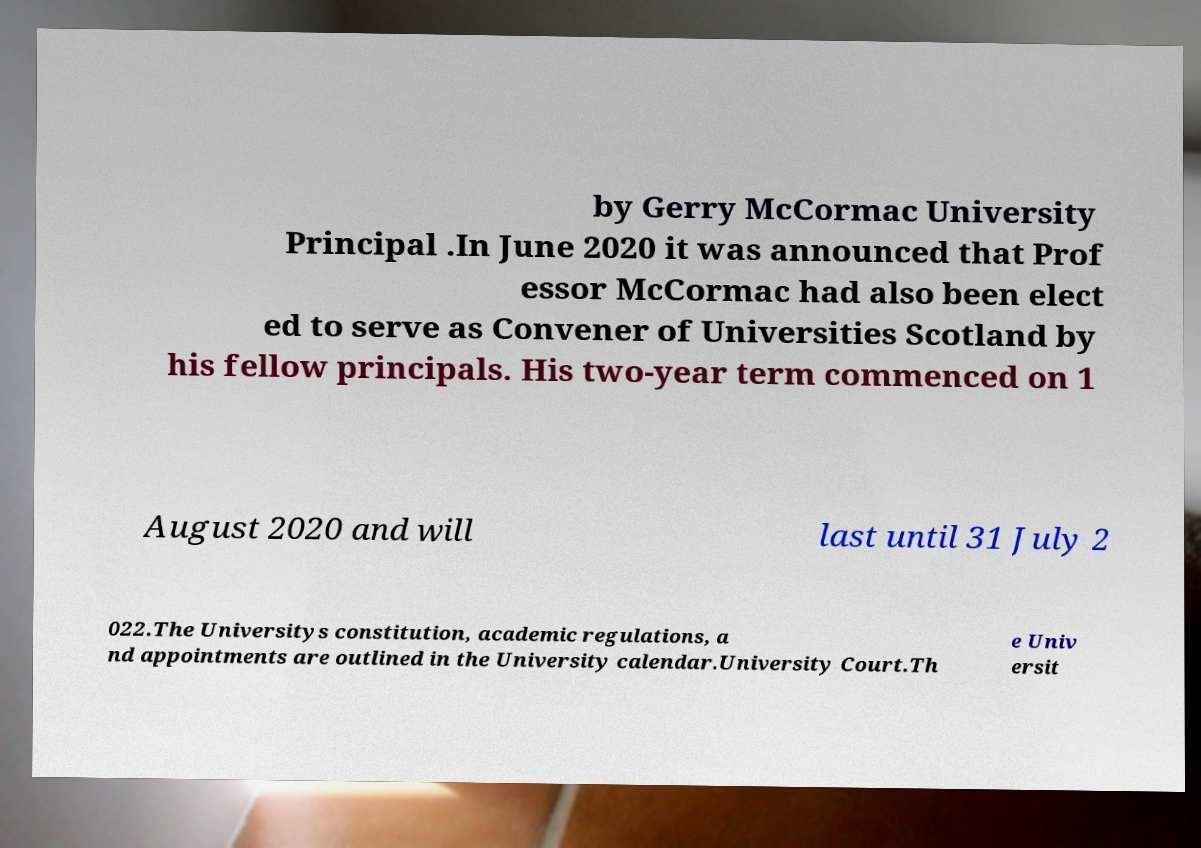There's text embedded in this image that I need extracted. Can you transcribe it verbatim? by Gerry McCormac University Principal .In June 2020 it was announced that Prof essor McCormac had also been elect ed to serve as Convener of Universities Scotland by his fellow principals. His two-year term commenced on 1 August 2020 and will last until 31 July 2 022.The Universitys constitution, academic regulations, a nd appointments are outlined in the University calendar.University Court.Th e Univ ersit 